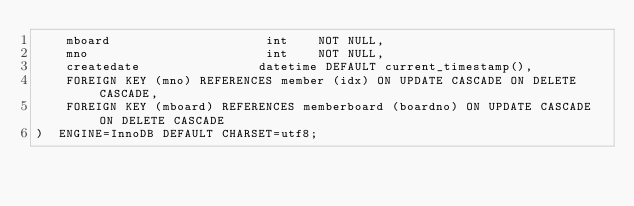<code> <loc_0><loc_0><loc_500><loc_500><_SQL_>    mboard                     int    NOT NULL,    
    mno                        int    NOT NULL,
    createdate                datetime DEFAULT current_timestamp(),
    FOREIGN KEY (mno) REFERENCES member (idx) ON UPDATE CASCADE ON DELETE CASCADE,
    FOREIGN KEY (mboard) REFERENCES memberboard (boardno) ON UPDATE CASCADE ON DELETE CASCADE
)  ENGINE=InnoDB DEFAULT CHARSET=utf8;</code> 